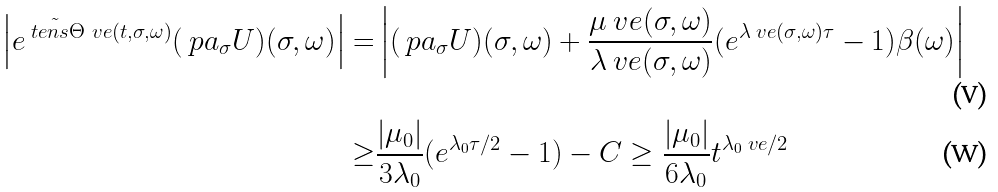<formula> <loc_0><loc_0><loc_500><loc_500>\left | e ^ { \tilde { \ t e n s { \Theta } } _ { \ } v e ( t , \sigma , \omega ) } ( \ p a _ { \sigma } U ) ( \sigma , \omega ) \right | = & \left | ( \ p a _ { \sigma } U ) ( \sigma , \omega ) + \frac { \mu _ { \ } v e ( \sigma , \omega ) } { \lambda _ { \ } v e ( \sigma , \omega ) } ( e ^ { \lambda _ { \ } v e ( \sigma , \omega ) \tau } - 1 ) \beta ( \omega ) \right | \\ \geq & \frac { | \mu _ { 0 } | } { 3 \lambda _ { 0 } } ( e ^ { \lambda _ { 0 } \tau / 2 } - 1 ) - C \geq \frac { | \mu _ { 0 } | } { 6 \lambda _ { 0 } } t ^ { \lambda _ { 0 } \ v e / 2 }</formula> 